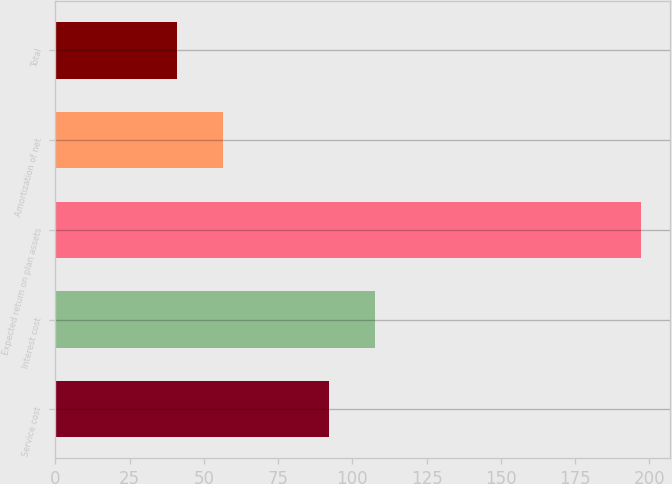Convert chart to OTSL. <chart><loc_0><loc_0><loc_500><loc_500><bar_chart><fcel>Service cost<fcel>Interest cost<fcel>Expected return on plan assets<fcel>Amortization of net<fcel>Total<nl><fcel>92<fcel>107.6<fcel>197<fcel>56.6<fcel>41<nl></chart> 